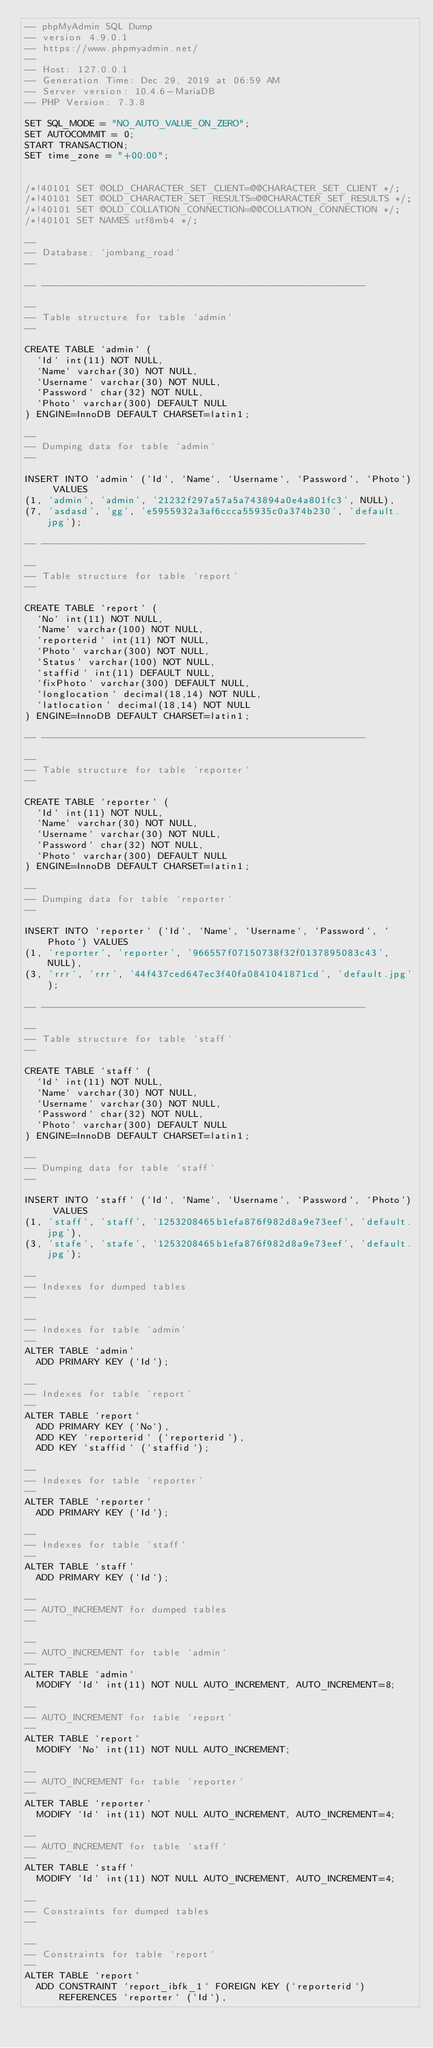Convert code to text. <code><loc_0><loc_0><loc_500><loc_500><_SQL_>-- phpMyAdmin SQL Dump
-- version 4.9.0.1
-- https://www.phpmyadmin.net/
--
-- Host: 127.0.0.1
-- Generation Time: Dec 29, 2019 at 06:59 AM
-- Server version: 10.4.6-MariaDB
-- PHP Version: 7.3.8

SET SQL_MODE = "NO_AUTO_VALUE_ON_ZERO";
SET AUTOCOMMIT = 0;
START TRANSACTION;
SET time_zone = "+00:00";


/*!40101 SET @OLD_CHARACTER_SET_CLIENT=@@CHARACTER_SET_CLIENT */;
/*!40101 SET @OLD_CHARACTER_SET_RESULTS=@@CHARACTER_SET_RESULTS */;
/*!40101 SET @OLD_COLLATION_CONNECTION=@@COLLATION_CONNECTION */;
/*!40101 SET NAMES utf8mb4 */;

--
-- Database: `jombang_road`
--

-- --------------------------------------------------------

--
-- Table structure for table `admin`
--

CREATE TABLE `admin` (
  `Id` int(11) NOT NULL,
  `Name` varchar(30) NOT NULL,
  `Username` varchar(30) NOT NULL,
  `Password` char(32) NOT NULL,
  `Photo` varchar(300) DEFAULT NULL
) ENGINE=InnoDB DEFAULT CHARSET=latin1;

--
-- Dumping data for table `admin`
--

INSERT INTO `admin` (`Id`, `Name`, `Username`, `Password`, `Photo`) VALUES
(1, 'admin', 'admin', '21232f297a57a5a743894a0e4a801fc3', NULL),
(7, 'asdasd', 'gg', 'e5955932a3af6ccca55935c0a374b230', 'default.jpg');

-- --------------------------------------------------------

--
-- Table structure for table `report`
--

CREATE TABLE `report` (
  `No` int(11) NOT NULL,
  `Name` varchar(100) NOT NULL,
  `reporterid` int(11) NOT NULL,
  `Photo` varchar(300) NOT NULL,
  `Status` varchar(100) NOT NULL,
  `staffid` int(11) DEFAULT NULL,
  `fixPhoto` varchar(300) DEFAULT NULL,
  `longlocation` decimal(18,14) NOT NULL,
  `latlocation` decimal(18,14) NOT NULL
) ENGINE=InnoDB DEFAULT CHARSET=latin1;

-- --------------------------------------------------------

--
-- Table structure for table `reporter`
--

CREATE TABLE `reporter` (
  `Id` int(11) NOT NULL,
  `Name` varchar(30) NOT NULL,
  `Username` varchar(30) NOT NULL,
  `Password` char(32) NOT NULL,
  `Photo` varchar(300) DEFAULT NULL
) ENGINE=InnoDB DEFAULT CHARSET=latin1;

--
-- Dumping data for table `reporter`
--

INSERT INTO `reporter` (`Id`, `Name`, `Username`, `Password`, `Photo`) VALUES
(1, 'reporter', 'reporter', '966557f07150738f32f0137895083c43', NULL),
(3, 'rrr', 'rrr', '44f437ced647ec3f40fa0841041871cd', 'default.jpg');

-- --------------------------------------------------------

--
-- Table structure for table `staff`
--

CREATE TABLE `staff` (
  `Id` int(11) NOT NULL,
  `Name` varchar(30) NOT NULL,
  `Username` varchar(30) NOT NULL,
  `Password` char(32) NOT NULL,
  `Photo` varchar(300) DEFAULT NULL
) ENGINE=InnoDB DEFAULT CHARSET=latin1;

--
-- Dumping data for table `staff`
--

INSERT INTO `staff` (`Id`, `Name`, `Username`, `Password`, `Photo`) VALUES
(1, 'staff', 'staff', '1253208465b1efa876f982d8a9e73eef', 'default.jpg'),
(3, 'stafe', 'stafe', '1253208465b1efa876f982d8a9e73eef', 'default.jpg');

--
-- Indexes for dumped tables
--

--
-- Indexes for table `admin`
--
ALTER TABLE `admin`
  ADD PRIMARY KEY (`Id`);

--
-- Indexes for table `report`
--
ALTER TABLE `report`
  ADD PRIMARY KEY (`No`),
  ADD KEY `reporterid` (`reporterid`),
  ADD KEY `staffid` (`staffid`);

--
-- Indexes for table `reporter`
--
ALTER TABLE `reporter`
  ADD PRIMARY KEY (`Id`);

--
-- Indexes for table `staff`
--
ALTER TABLE `staff`
  ADD PRIMARY KEY (`Id`);

--
-- AUTO_INCREMENT for dumped tables
--

--
-- AUTO_INCREMENT for table `admin`
--
ALTER TABLE `admin`
  MODIFY `Id` int(11) NOT NULL AUTO_INCREMENT, AUTO_INCREMENT=8;

--
-- AUTO_INCREMENT for table `report`
--
ALTER TABLE `report`
  MODIFY `No` int(11) NOT NULL AUTO_INCREMENT;

--
-- AUTO_INCREMENT for table `reporter`
--
ALTER TABLE `reporter`
  MODIFY `Id` int(11) NOT NULL AUTO_INCREMENT, AUTO_INCREMENT=4;

--
-- AUTO_INCREMENT for table `staff`
--
ALTER TABLE `staff`
  MODIFY `Id` int(11) NOT NULL AUTO_INCREMENT, AUTO_INCREMENT=4;

--
-- Constraints for dumped tables
--

--
-- Constraints for table `report`
--
ALTER TABLE `report`
  ADD CONSTRAINT `report_ibfk_1` FOREIGN KEY (`reporterid`) REFERENCES `reporter` (`Id`),</code> 